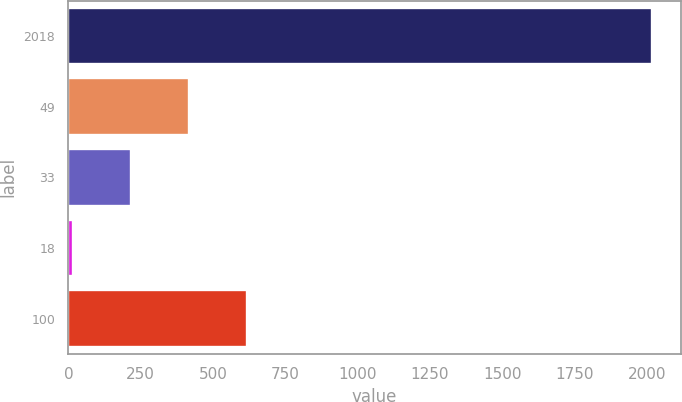Convert chart to OTSL. <chart><loc_0><loc_0><loc_500><loc_500><bar_chart><fcel>2018<fcel>49<fcel>33<fcel>18<fcel>100<nl><fcel>2017<fcel>416.2<fcel>216.1<fcel>16<fcel>616.3<nl></chart> 